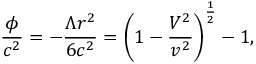Convert formula to latex. <formula><loc_0><loc_0><loc_500><loc_500>\frac { \phi } { c ^ { 2 } } = - \frac { \Lambda r ^ { 2 } } { 6 c ^ { 2 } } = \left ( 1 - \frac { V ^ { 2 } } { v ^ { 2 } } \right ) ^ { \frac { 1 } { 2 } } - 1 ,</formula> 